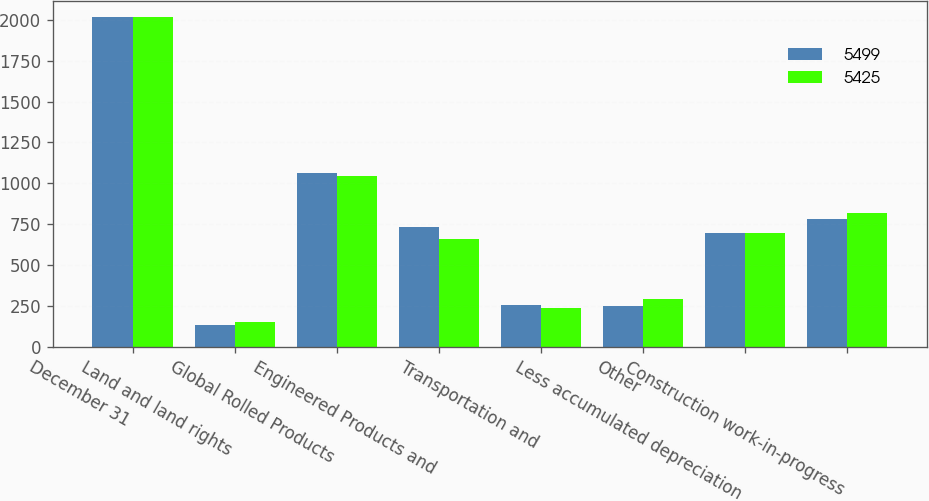Convert chart to OTSL. <chart><loc_0><loc_0><loc_500><loc_500><stacked_bar_chart><ecel><fcel>December 31<fcel>Land and land rights<fcel>Global Rolled Products<fcel>Engineered Products and<fcel>Transportation and<fcel>Other<fcel>Less accumulated depreciation<fcel>Construction work-in-progress<nl><fcel>5499<fcel>2016<fcel>135<fcel>1061<fcel>733<fcel>254<fcel>248<fcel>695.5<fcel>783<nl><fcel>5425<fcel>2015<fcel>149<fcel>1042<fcel>658<fcel>239<fcel>290<fcel>695.5<fcel>821<nl></chart> 